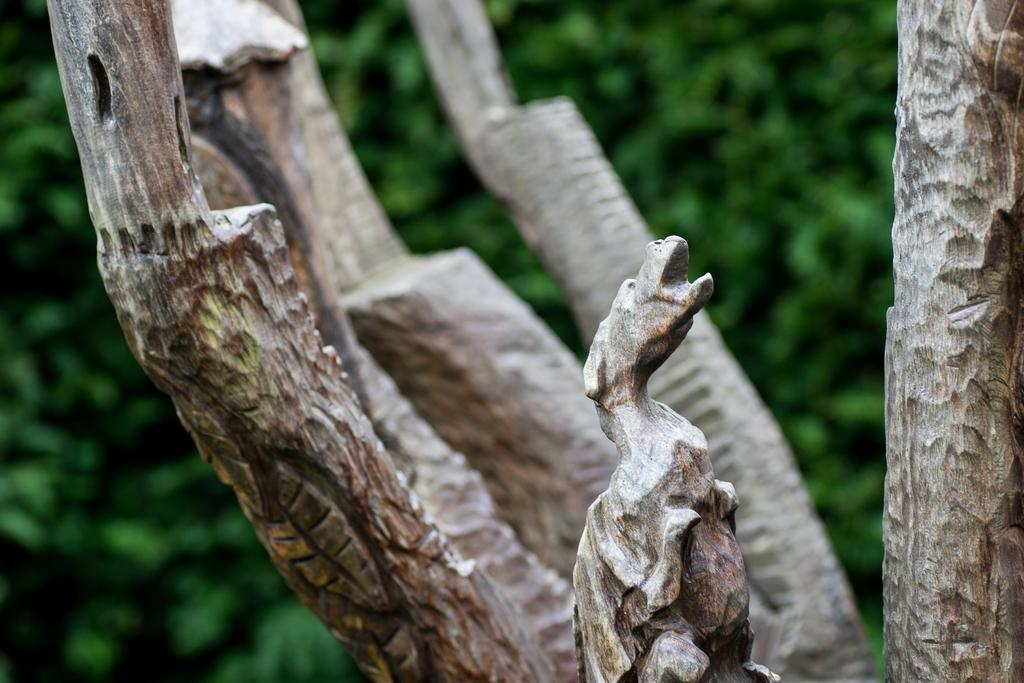What is the main subject of the image? There is a statue in the image. What else can be seen in the image besides the statue? There are branches in the image. What color is predominant in the background of the image? The background of the image is green. What type of list can be seen hanging from the statue in the image? There is no list present in the image; it features a statue and branches with a green background. 